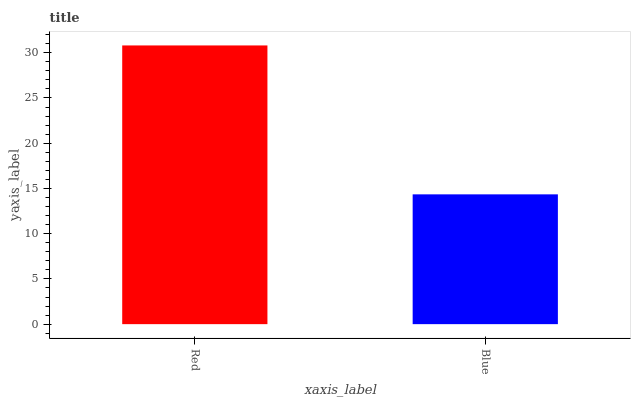Is Blue the minimum?
Answer yes or no. Yes. Is Red the maximum?
Answer yes or no. Yes. Is Blue the maximum?
Answer yes or no. No. Is Red greater than Blue?
Answer yes or no. Yes. Is Blue less than Red?
Answer yes or no. Yes. Is Blue greater than Red?
Answer yes or no. No. Is Red less than Blue?
Answer yes or no. No. Is Red the high median?
Answer yes or no. Yes. Is Blue the low median?
Answer yes or no. Yes. Is Blue the high median?
Answer yes or no. No. Is Red the low median?
Answer yes or no. No. 